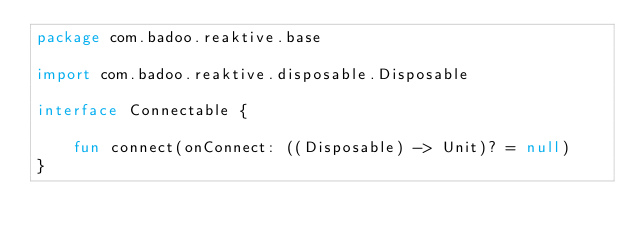Convert code to text. <code><loc_0><loc_0><loc_500><loc_500><_Kotlin_>package com.badoo.reaktive.base

import com.badoo.reaktive.disposable.Disposable

interface Connectable {

    fun connect(onConnect: ((Disposable) -> Unit)? = null)
}
</code> 